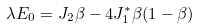<formula> <loc_0><loc_0><loc_500><loc_500>\lambda E _ { 0 } = J _ { 2 } \beta - 4 J ^ { * } _ { 1 } \beta ( 1 - \beta )</formula> 